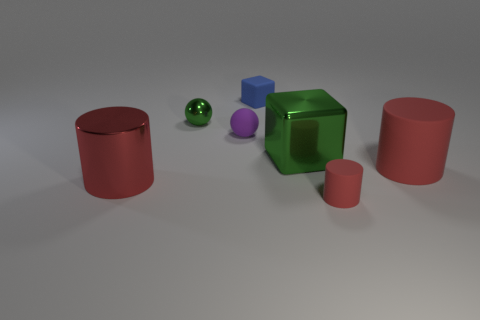Subtract all rubber cylinders. How many cylinders are left? 1 Add 2 matte things. How many objects exist? 9 Add 1 cylinders. How many cylinders exist? 4 Subtract 0 brown balls. How many objects are left? 7 Subtract all cylinders. How many objects are left? 4 Subtract 3 cylinders. How many cylinders are left? 0 Subtract all yellow cubes. Subtract all gray cylinders. How many cubes are left? 2 Subtract all red balls. How many green cubes are left? 1 Subtract all green shiny objects. Subtract all metal cylinders. How many objects are left? 4 Add 2 big green metallic cubes. How many big green metallic cubes are left? 3 